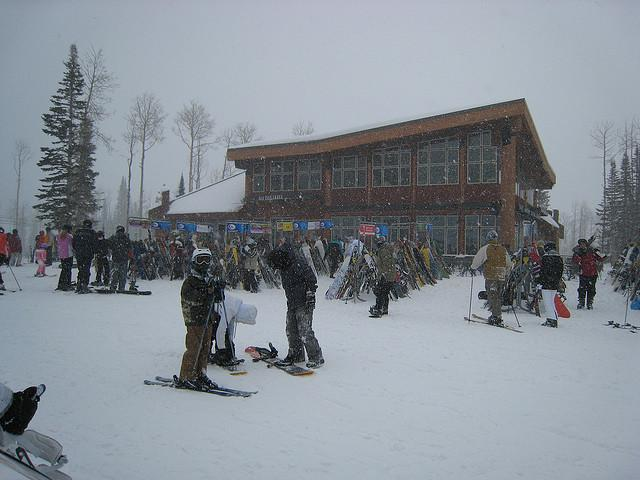Which weather phenomenon is likely to be most frustrating to people seen here at this place?

Choices:
A) hard freeze
B) snow
C) heat wave
D) cool wind heat wave 